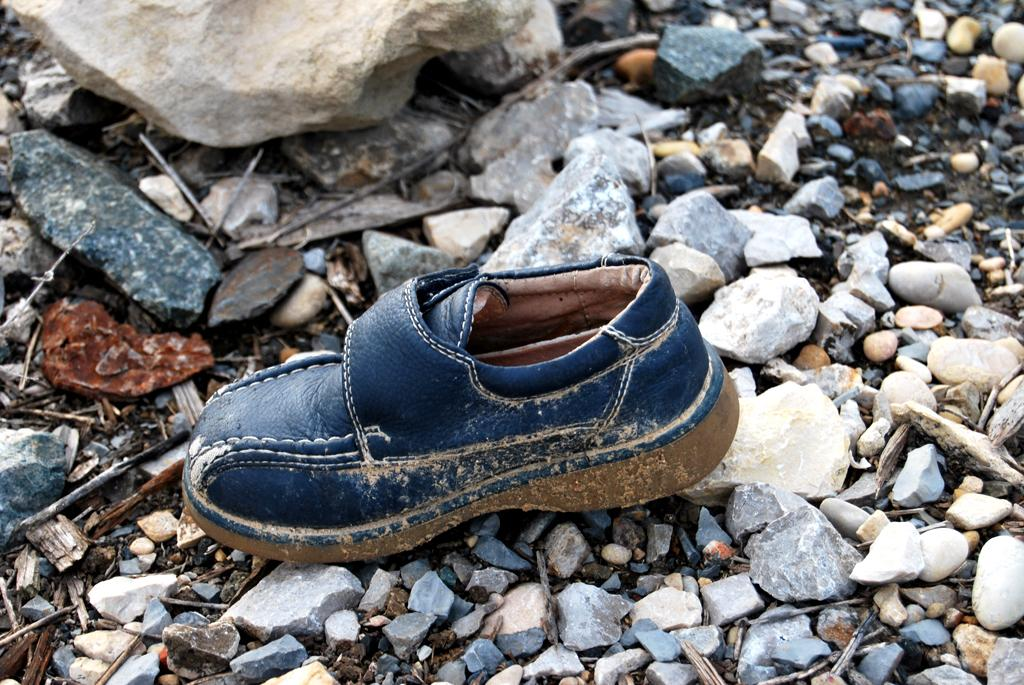What object can be seen in the image that people wear on their feet? There is a shoe in the image. What type of natural elements are present in the image? There are stones in the image. What other objects can be seen in the image made of natural materials? There are wood sticks in the image. Can you determine the time of day when the image was taken? The image was likely taken during the day, as there is sufficient light to see the objects clearly. What type of paper is being used by the tramp in the image? There is no tramp or paper present in the image. 